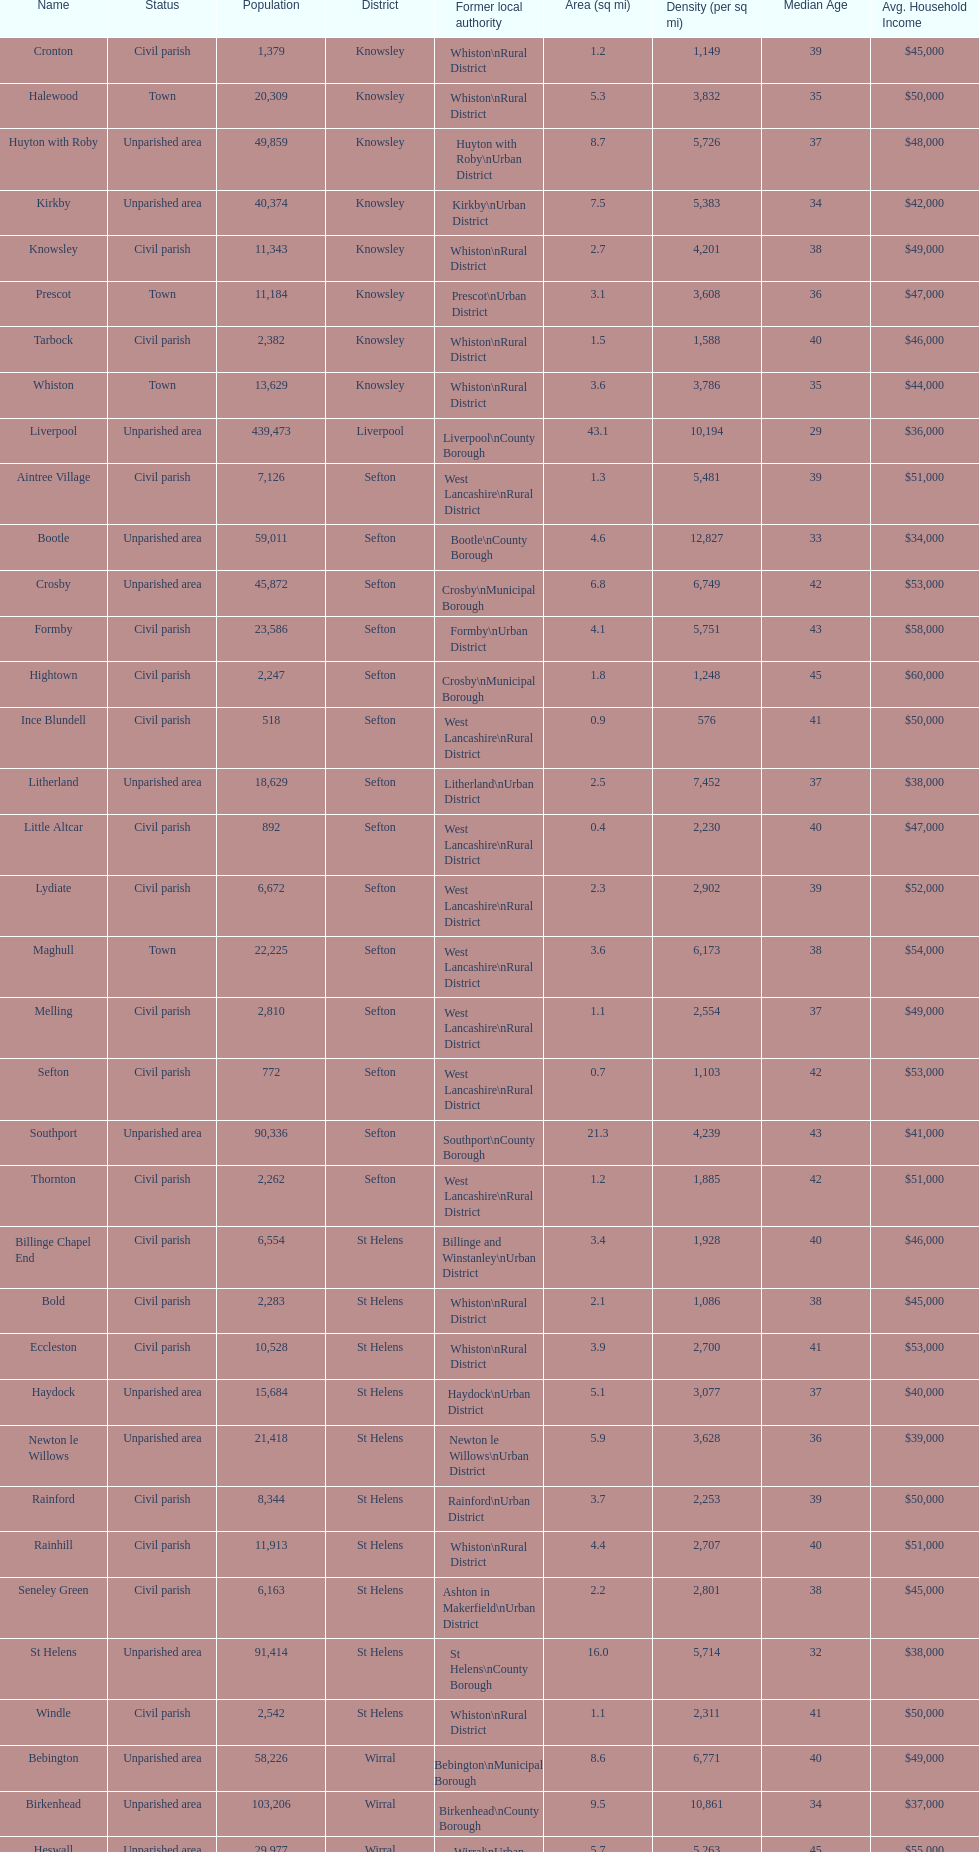What is the largest area in terms of population? Liverpool. 